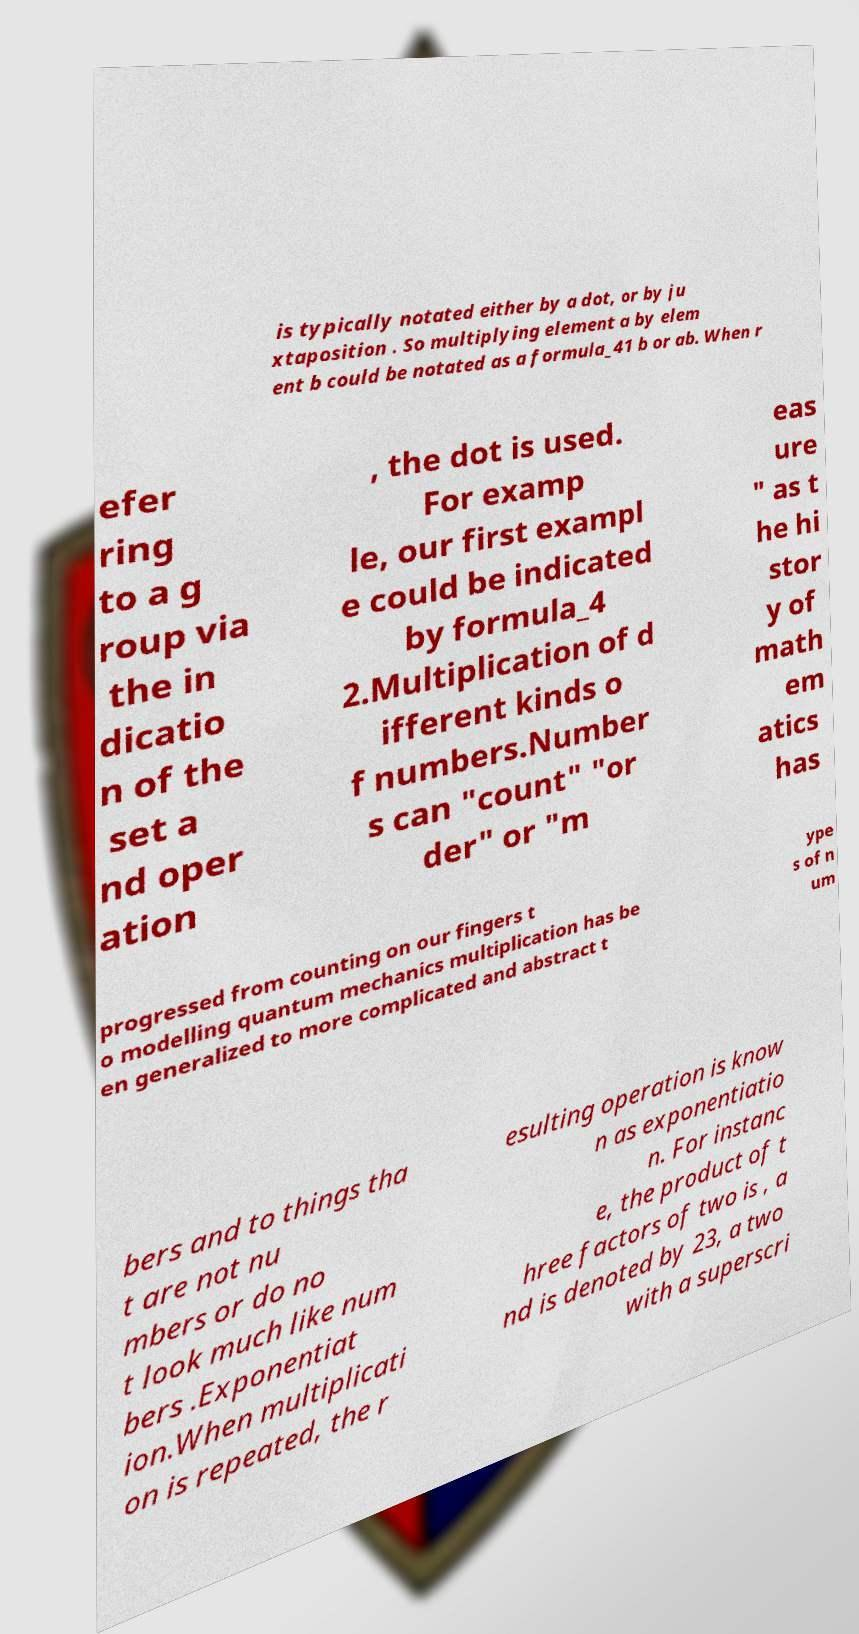Can you accurately transcribe the text from the provided image for me? is typically notated either by a dot, or by ju xtaposition . So multiplying element a by elem ent b could be notated as a formula_41 b or ab. When r efer ring to a g roup via the in dicatio n of the set a nd oper ation , the dot is used. For examp le, our first exampl e could be indicated by formula_4 2.Multiplication of d ifferent kinds o f numbers.Number s can "count" "or der" or "m eas ure " as t he hi stor y of math em atics has progressed from counting on our fingers t o modelling quantum mechanics multiplication has be en generalized to more complicated and abstract t ype s of n um bers and to things tha t are not nu mbers or do no t look much like num bers .Exponentiat ion.When multiplicati on is repeated, the r esulting operation is know n as exponentiatio n. For instanc e, the product of t hree factors of two is , a nd is denoted by 23, a two with a superscri 